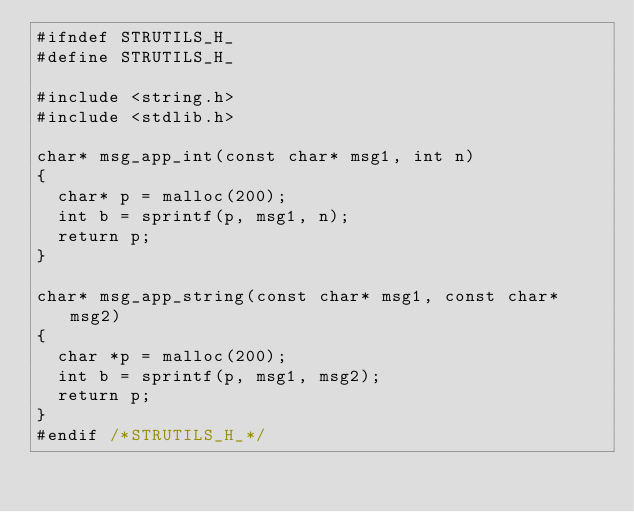Convert code to text. <code><loc_0><loc_0><loc_500><loc_500><_C_>#ifndef STRUTILS_H_
#define STRUTILS_H_

#include <string.h>
#include <stdlib.h>

char* msg_app_int(const char* msg1, int n)
{
	char* p = malloc(200);
	int b = sprintf(p, msg1, n);
	return p;
}

char* msg_app_string(const char* msg1, const char* msg2)
{
	char *p = malloc(200);
	int b = sprintf(p, msg1, msg2);
	return p;
}
#endif /*STRUTILS_H_*/
</code> 